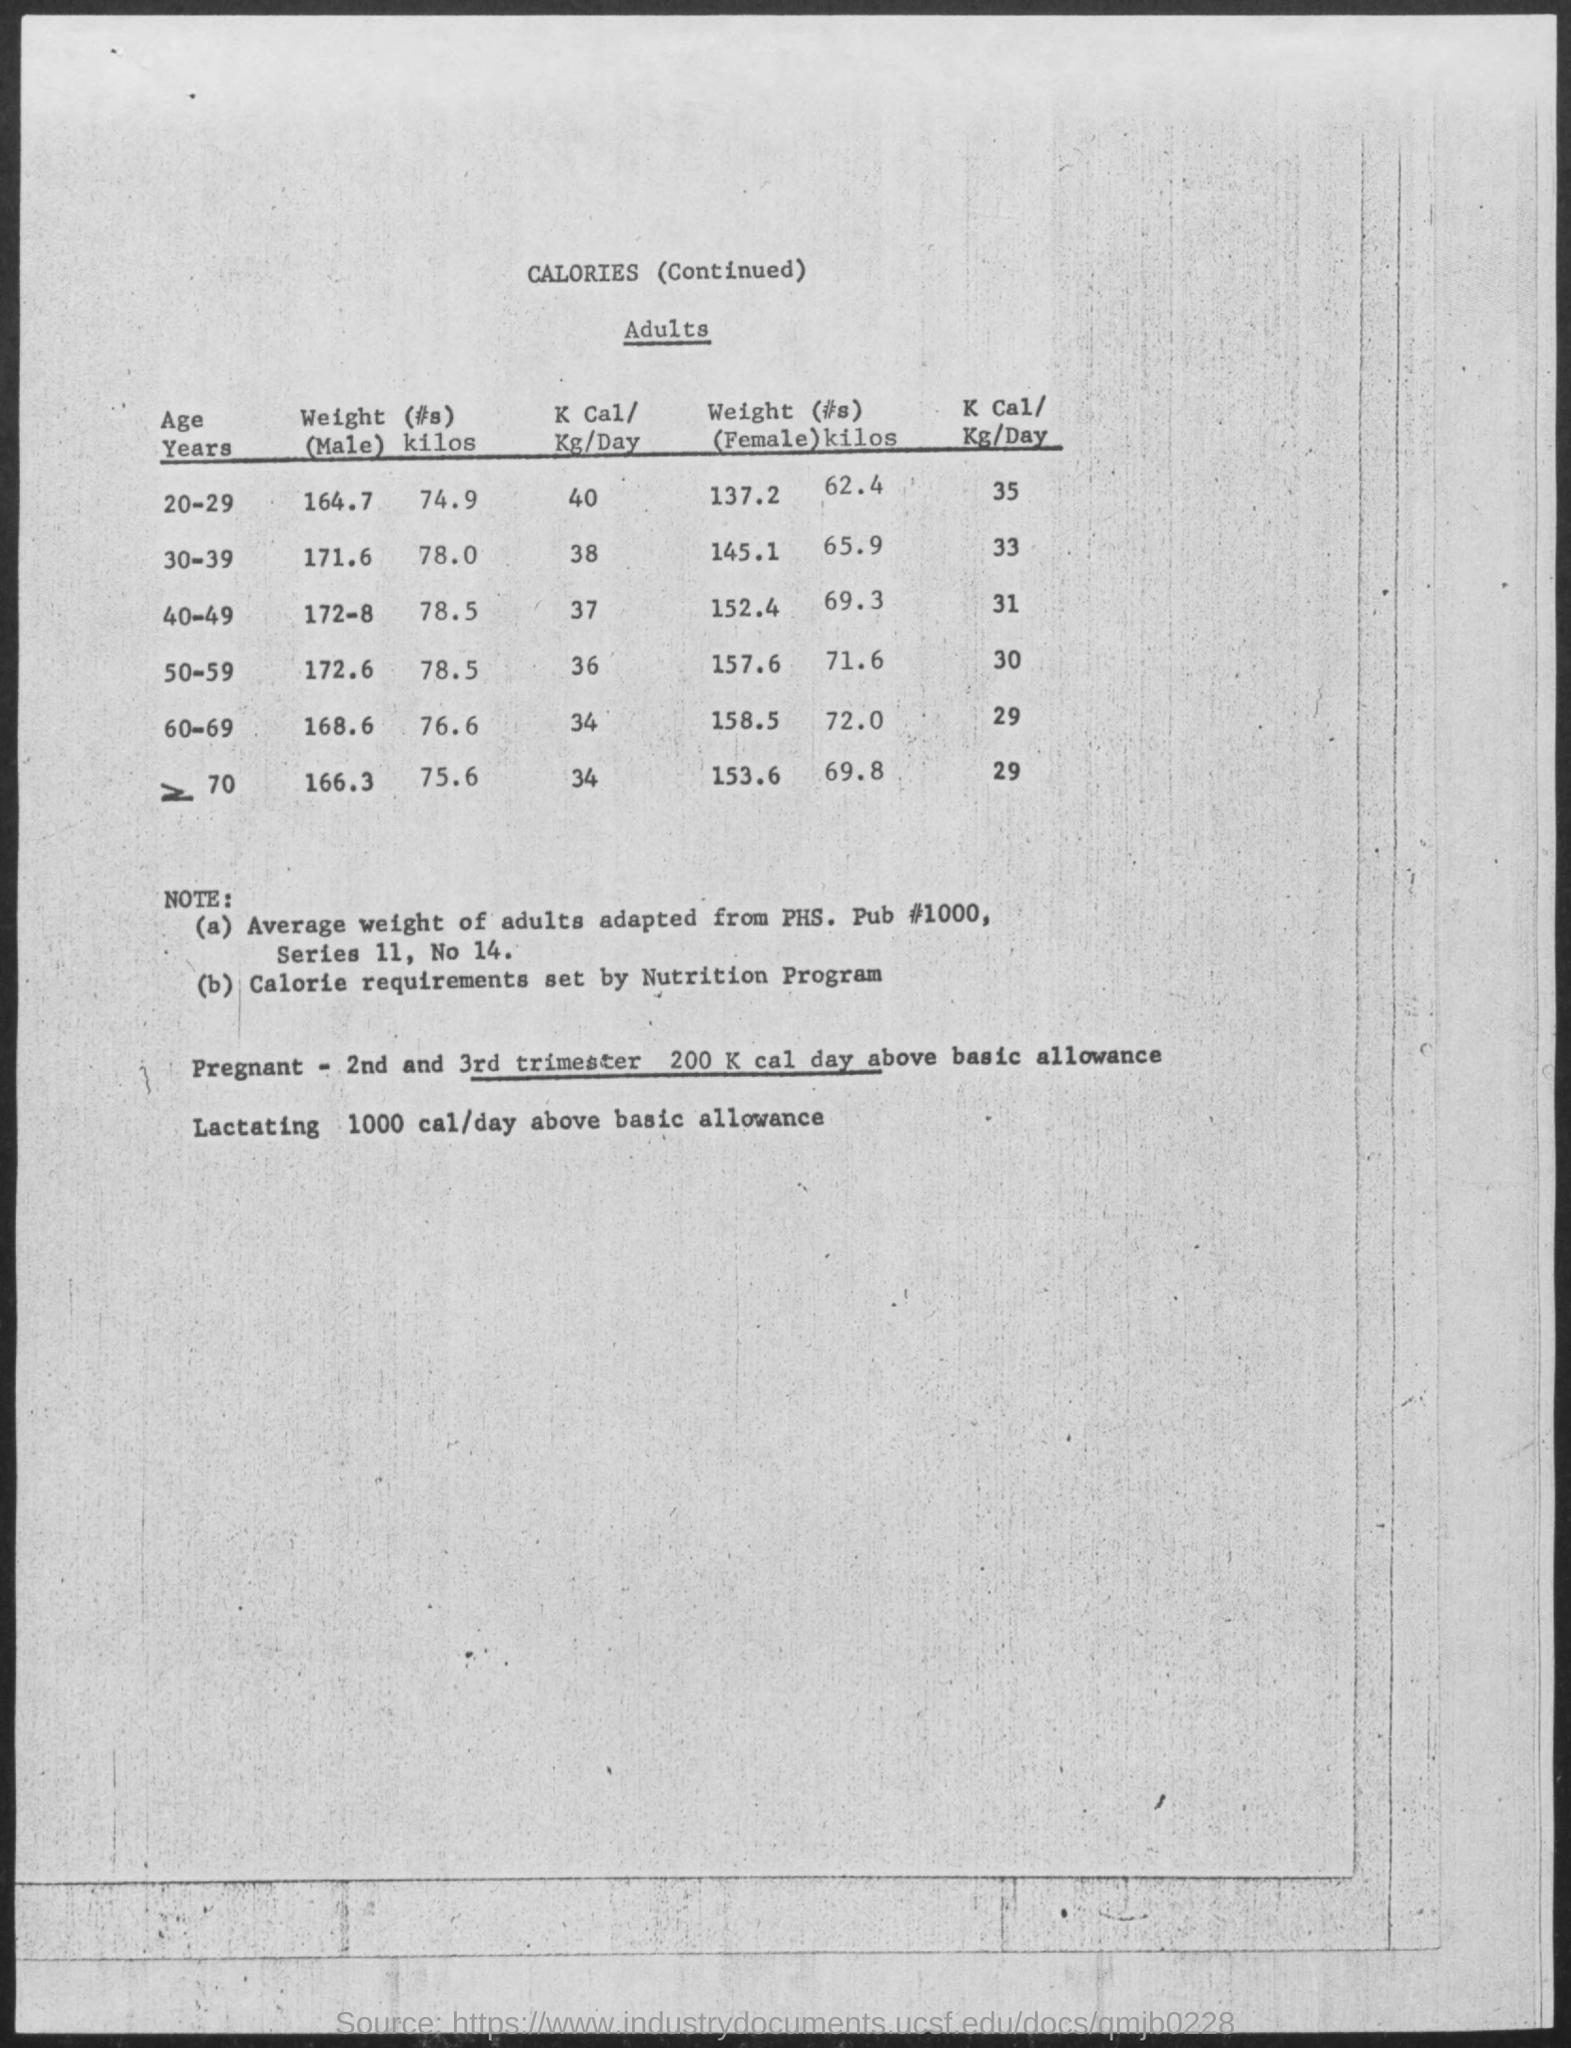Outline some significant characteristics in this image. The weight for a female aged 50-59 is 157.6. The weight for a female aged 20-29 is 137.2 pounds. The weight for a male aged 40-49 is 172.8 pounds. The weight for a male aged 60-69 is 168.6. The weight for males aged 20-29 is 164.7. 